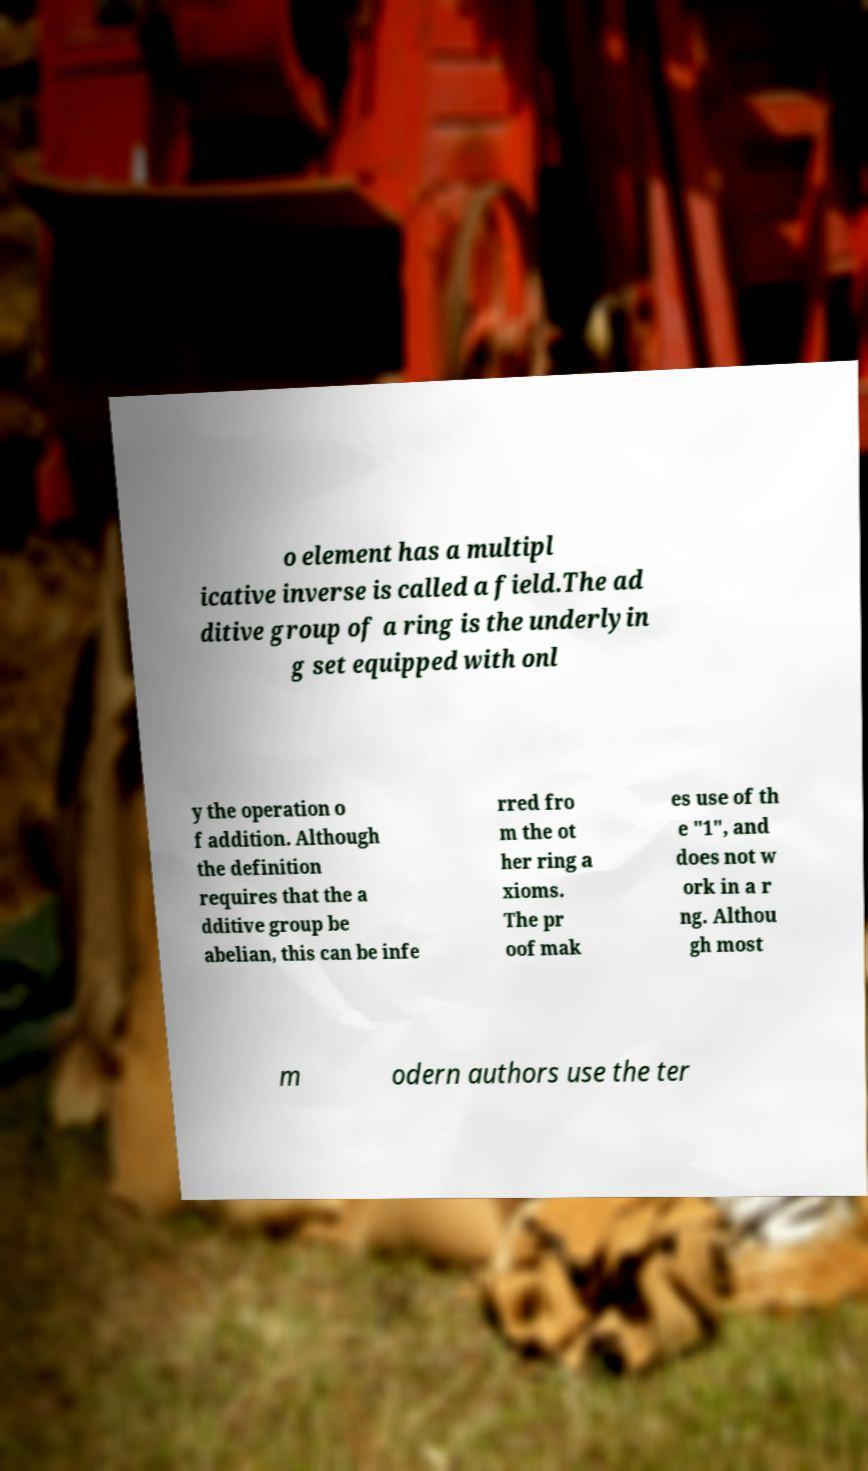Can you accurately transcribe the text from the provided image for me? o element has a multipl icative inverse is called a field.The ad ditive group of a ring is the underlyin g set equipped with onl y the operation o f addition. Although the definition requires that the a dditive group be abelian, this can be infe rred fro m the ot her ring a xioms. The pr oof mak es use of th e "1", and does not w ork in a r ng. Althou gh most m odern authors use the ter 